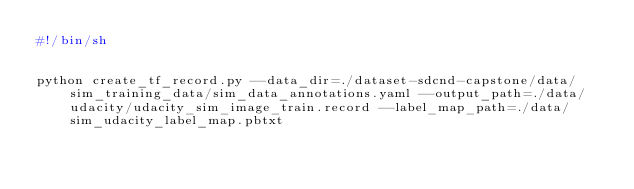Convert code to text. <code><loc_0><loc_0><loc_500><loc_500><_Bash_>#!/bin/sh


python create_tf_record.py --data_dir=./dataset-sdcnd-capstone/data/sim_training_data/sim_data_annotations.yaml --output_path=./data/udacity/udacity_sim_image_train.record --label_map_path=./data/sim_udacity_label_map.pbtxt
</code> 